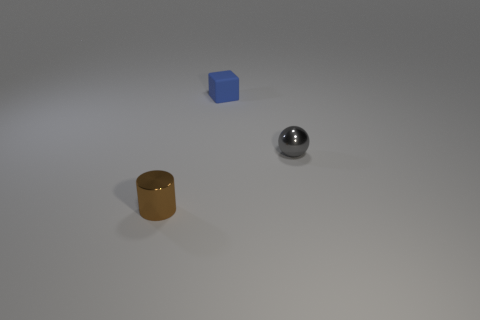Add 1 tiny balls. How many objects exist? 4 Subtract all cylinders. How many objects are left? 2 Subtract all gray things. Subtract all brown shiny things. How many objects are left? 1 Add 2 blue blocks. How many blue blocks are left? 3 Add 1 cylinders. How many cylinders exist? 2 Subtract 0 purple spheres. How many objects are left? 3 